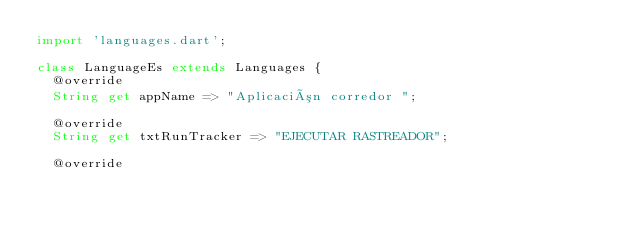Convert code to text. <code><loc_0><loc_0><loc_500><loc_500><_Dart_>import 'languages.dart';

class LanguageEs extends Languages {
  @override
  String get appName => "Aplicación corredor ";

  @override
  String get txtRunTracker => "EJECUTAR RASTREADOR";

  @override</code> 